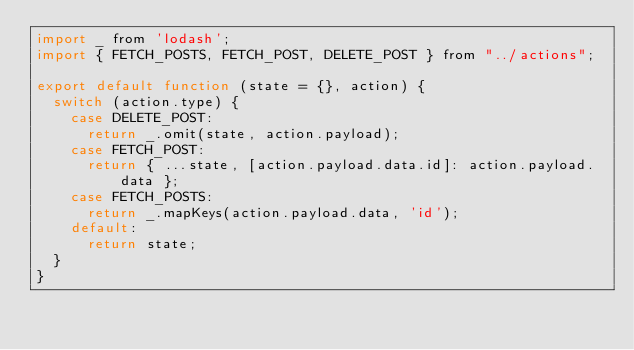<code> <loc_0><loc_0><loc_500><loc_500><_JavaScript_>import _ from 'lodash';
import { FETCH_POSTS, FETCH_POST, DELETE_POST } from "../actions";

export default function (state = {}, action) {
  switch (action.type) {
    case DELETE_POST:
      return _.omit(state, action.payload);
    case FETCH_POST:
      return { ...state, [action.payload.data.id]: action.payload.data };
    case FETCH_POSTS:
      return _.mapKeys(action.payload.data, 'id');
    default:
      return state;
  }
}</code> 